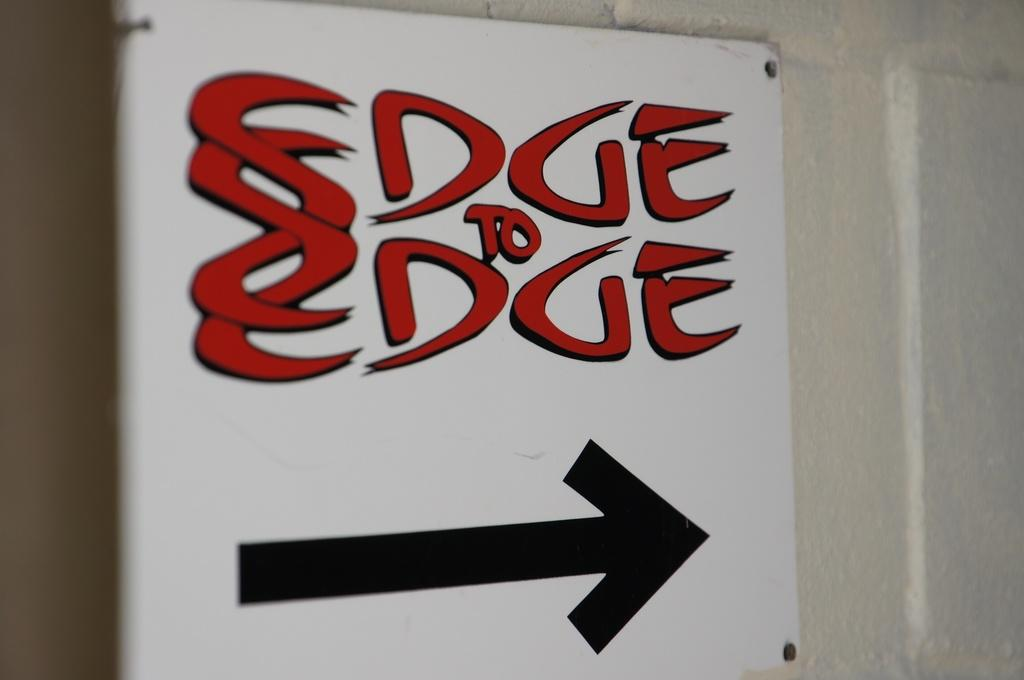Provide a one-sentence caption for the provided image. A sign attached to a wall. It says Edge to Edge and had a black arrow pointing right. 